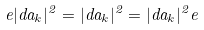Convert formula to latex. <formula><loc_0><loc_0><loc_500><loc_500>e | d a _ { k } | ^ { 2 } = | d a _ { k } | ^ { 2 } = | d a _ { k } | ^ { 2 } e</formula> 